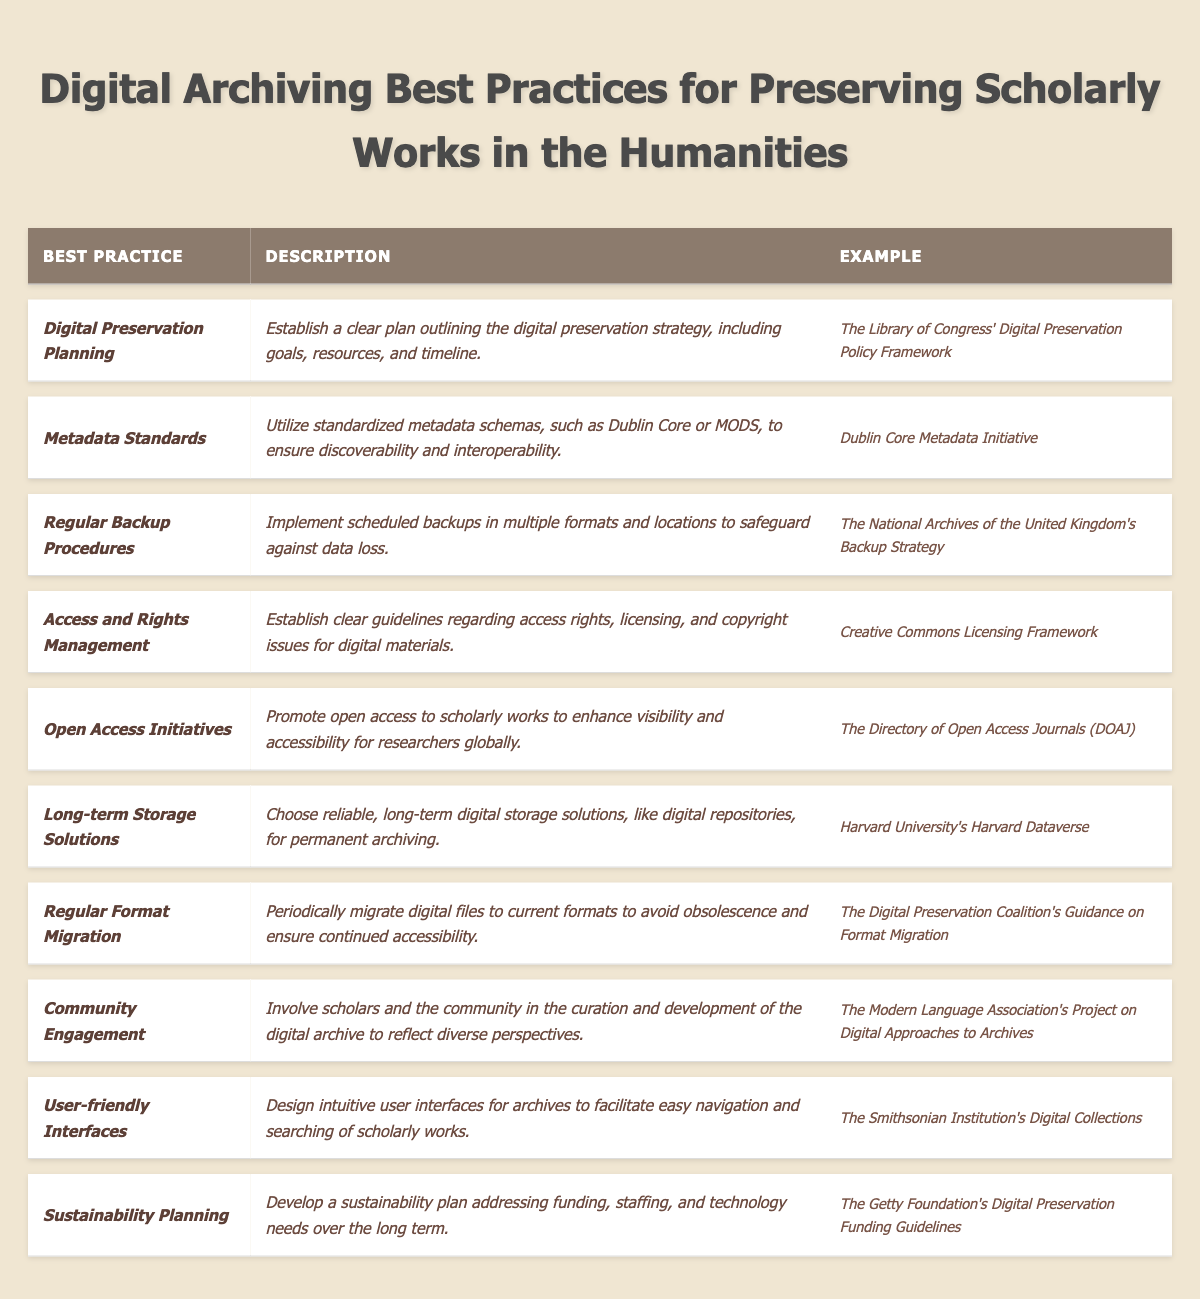What is the first best practice listed in the table? The first best practice in the table is found in the first row under the "Best Practice" column, which is "Digital Preservation Planning."
Answer: Digital Preservation Planning How many best practices are included in the table? The table consists of ten rows, each representing a distinct best practice, thus providing a total count of ten best practices.
Answer: 10 What is an example of the "Metadata Standards" best practice? The example associated with the "Metadata Standards" best practice is located in the same row under the "Example" column, which states "Dublin Core Metadata Initiative."
Answer: Dublin Core Metadata Initiative Is "User-friendly Interfaces" considered one of the best practices? By checking the "Best Practice" column, we can confirm that "User-friendly Interfaces" is indeed present, indicating it is a recognized best practice.
Answer: Yes Which best practice emphasizes community involvement? The "Community Engagement" best practice promotes involvement from scholars and the community in the archive's curation and development.
Answer: Community Engagement What is the last best practice listed in the table? The last entry in the "Best Practice" column corresponds to "Sustainability Planning," indicating it is the final best practice outlined in the table.
Answer: Sustainability Planning How many best practices specifically mention the need for planning or management? The table includes "Digital Preservation Planning," "Access and Rights Management," and "Sustainability Planning," totaling three practices that mention planning or management.
Answer: 3 Name an example associated with the best practice of "Open Access Initiatives." The example provided for "Open Access Initiatives" in the corresponding row is "The Directory of Open Access Journals (DOAJ)."
Answer: The Directory of Open Access Journals (DOAJ) What is the primary goal of "Regular Backup Procedures"? The goal of "Regular Backup Procedures" is to implement scheduled backups in multiple formats and locations to protect against data loss.
Answer: To safeguard against data loss Which best practice would you refer to for guidelines on access rights? The "Access and Rights Management" best practice provides the necessary guidelines regarding access rights, licensing, and copyright issues for digital materials.
Answer: Access and Rights Management 